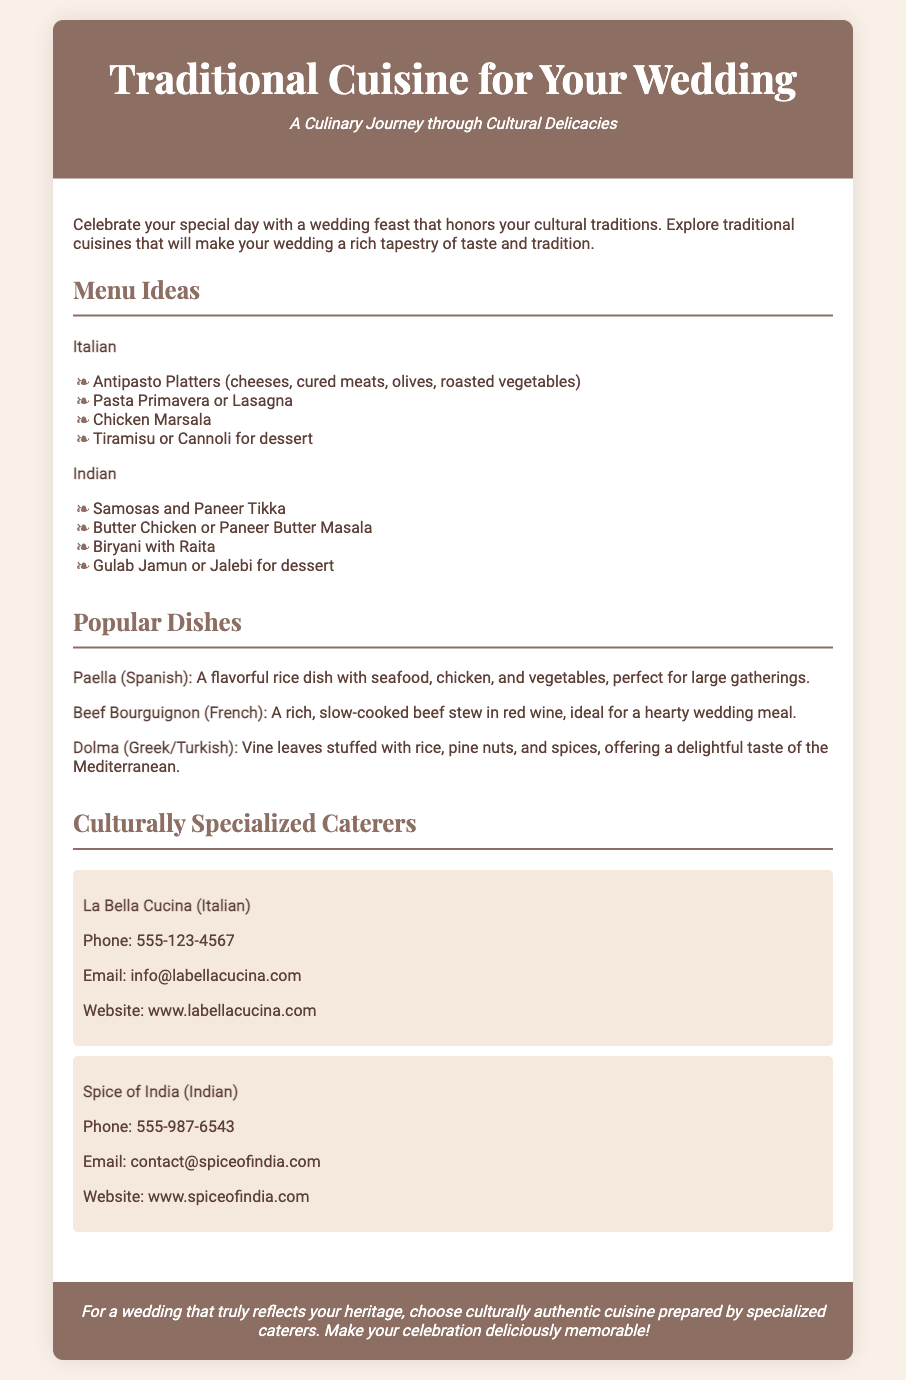What is the title of the flyer? The title is clearly stated at the top of the flyer in a large font.
Answer: Traditional Cuisine for Your Wedding What is the subtitle of the flyer? The subtitle provides a brief description of the theme of the flyer below the title.
Answer: A Culinary Journey through Cultural Delicacies Name one Italian menu idea listed in the flyer. The menu ideas section includes different cultural suggestions, specifically for Italian cuisine.
Answer: Antipasto Platters What dish is recommended for Indian cuisine in the menu ideas? The menu ideas list suggests popular dishes for each cuisine, including specific Indian options.
Answer: Samosas and Paneer Tikka How many culturally specialized caterers are mentioned in the flyer? The flyer includes a section listing caterers that focus on cultural cuisine, with their information provided.
Answer: Two What is one popular dish mentioned from Spanish cuisine? The popular dishes section highlights significant dishes from various cultural backgrounds.
Answer: Paella What is the contact phone number for La Bella Cucina? Each caterer listed in the flyer includes specific contact information for potential clients.
Answer: 555-123-4567 Which email address is provided for Spice of India? The flyer gives email contact details for the listed catering options.
Answer: contact@spiceofindia.com What cultural cuisine does the caterer "La Bella Cucina" specialize in? Each caterer listed identifies the specific cuisine they focus on within the flyer.
Answer: Italian 